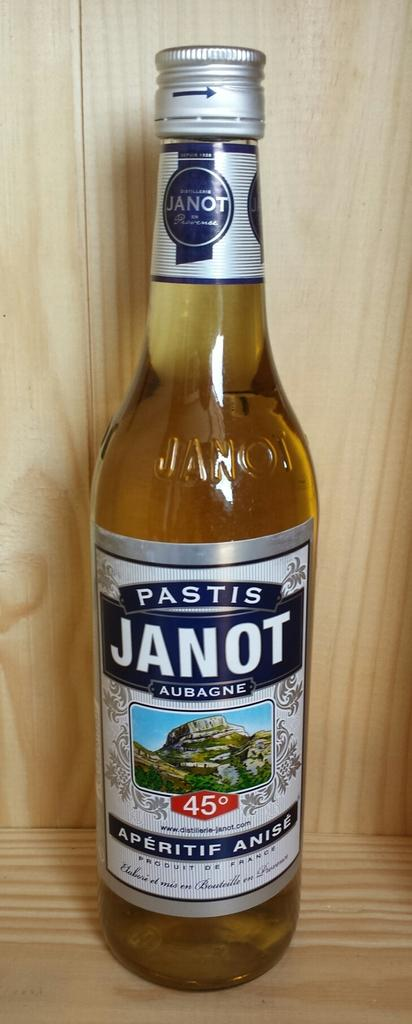<image>
Create a compact narrative representing the image presented. A bottle of beer has a label with the name Pastis Janot on it. 